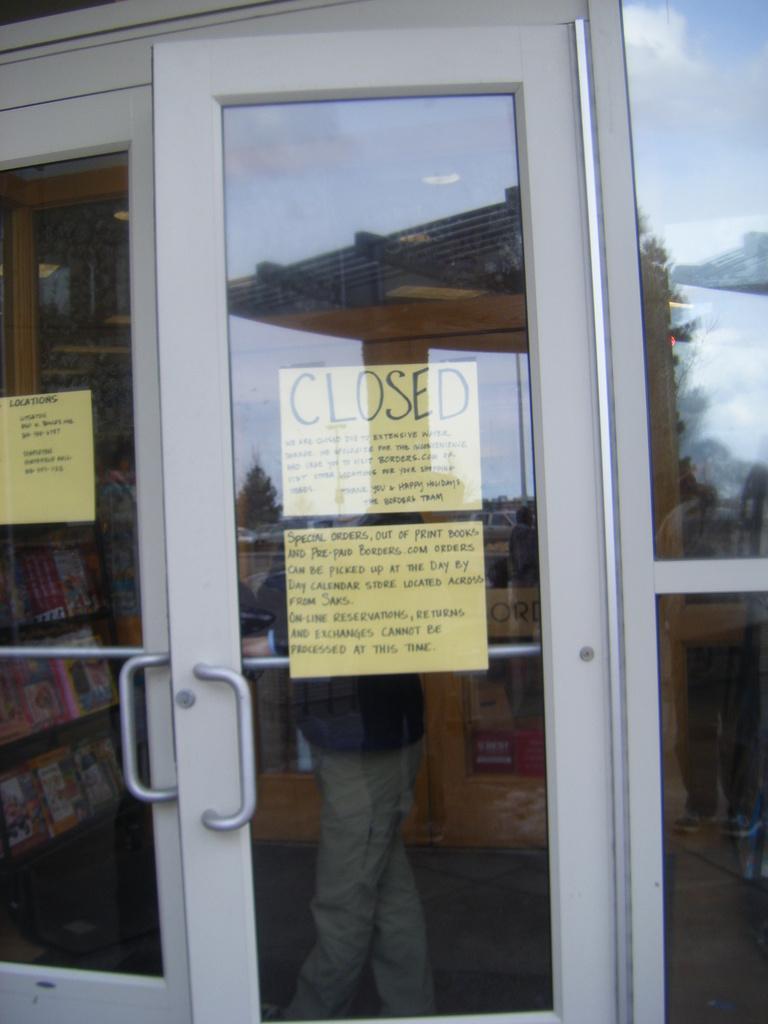Please provide a concise description of this image. In this image we can see doors. On the doors there are papers past. Also something is written on that. Through the door we can see a person. Also there are books on the racks. On the glass we can see reflection of sky with clouds. 